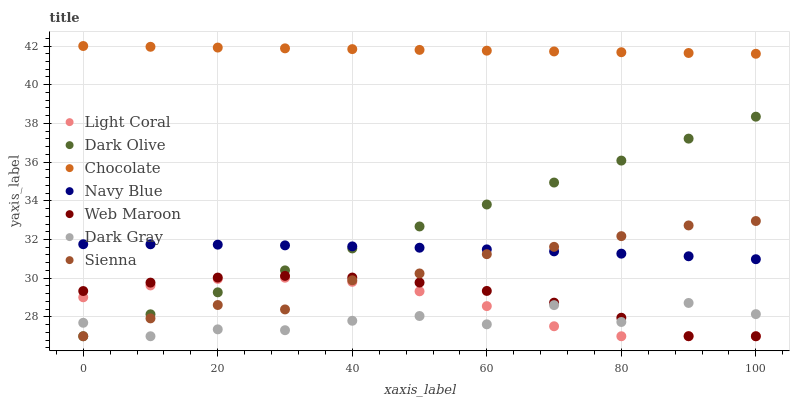Does Dark Gray have the minimum area under the curve?
Answer yes or no. Yes. Does Chocolate have the maximum area under the curve?
Answer yes or no. Yes. Does Navy Blue have the minimum area under the curve?
Answer yes or no. No. Does Navy Blue have the maximum area under the curve?
Answer yes or no. No. Is Chocolate the smoothest?
Answer yes or no. Yes. Is Dark Gray the roughest?
Answer yes or no. Yes. Is Navy Blue the smoothest?
Answer yes or no. No. Is Navy Blue the roughest?
Answer yes or no. No. Does Dark Gray have the lowest value?
Answer yes or no. Yes. Does Navy Blue have the lowest value?
Answer yes or no. No. Does Chocolate have the highest value?
Answer yes or no. Yes. Does Navy Blue have the highest value?
Answer yes or no. No. Is Web Maroon less than Chocolate?
Answer yes or no. Yes. Is Navy Blue greater than Web Maroon?
Answer yes or no. Yes. Does Dark Olive intersect Sienna?
Answer yes or no. Yes. Is Dark Olive less than Sienna?
Answer yes or no. No. Is Dark Olive greater than Sienna?
Answer yes or no. No. Does Web Maroon intersect Chocolate?
Answer yes or no. No. 